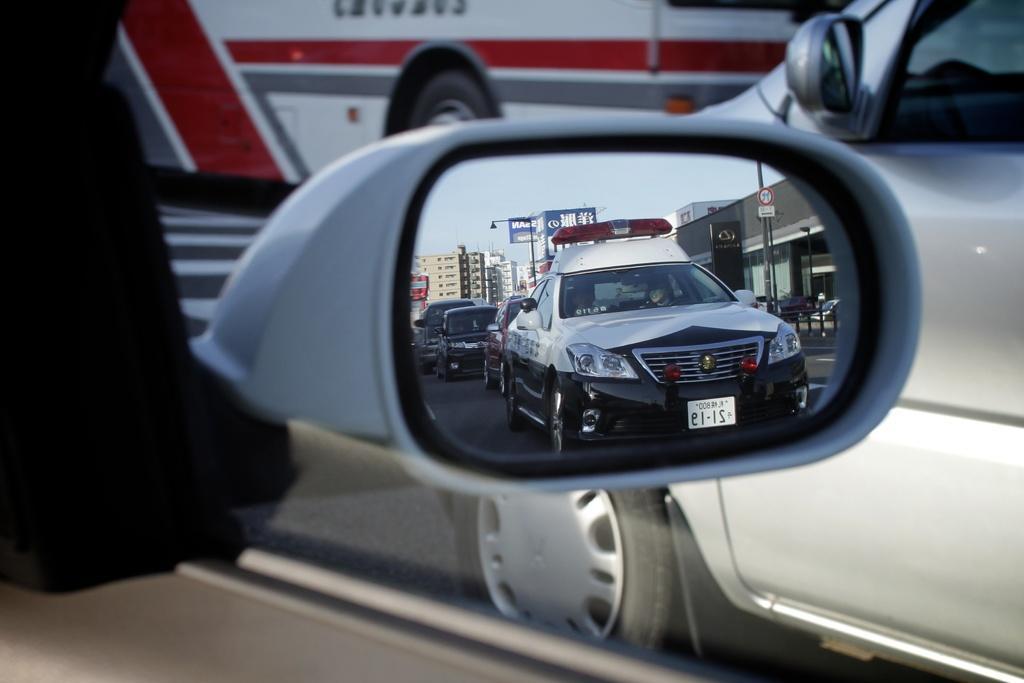Could you give a brief overview of what you see in this image? In this image, we can see a side mirror of the car, we can see the reflection of some cars in the mirror. We can see a bus, on the right side, we can see a car. 